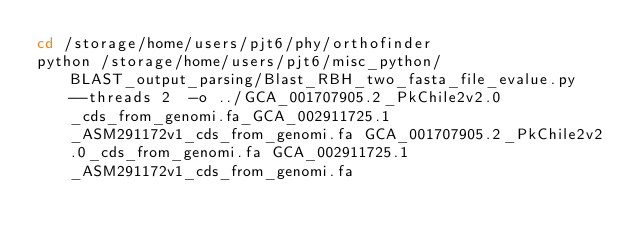Convert code to text. <code><loc_0><loc_0><loc_500><loc_500><_Bash_>cd /storage/home/users/pjt6/phy/orthofinder
python /storage/home/users/pjt6/misc_python/BLAST_output_parsing/Blast_RBH_two_fasta_file_evalue.py  --threads 2  -o ../GCA_001707905.2_PkChile2v2.0_cds_from_genomi.fa_GCA_002911725.1_ASM291172v1_cds_from_genomi.fa GCA_001707905.2_PkChile2v2.0_cds_from_genomi.fa GCA_002911725.1_ASM291172v1_cds_from_genomi.fa</code> 